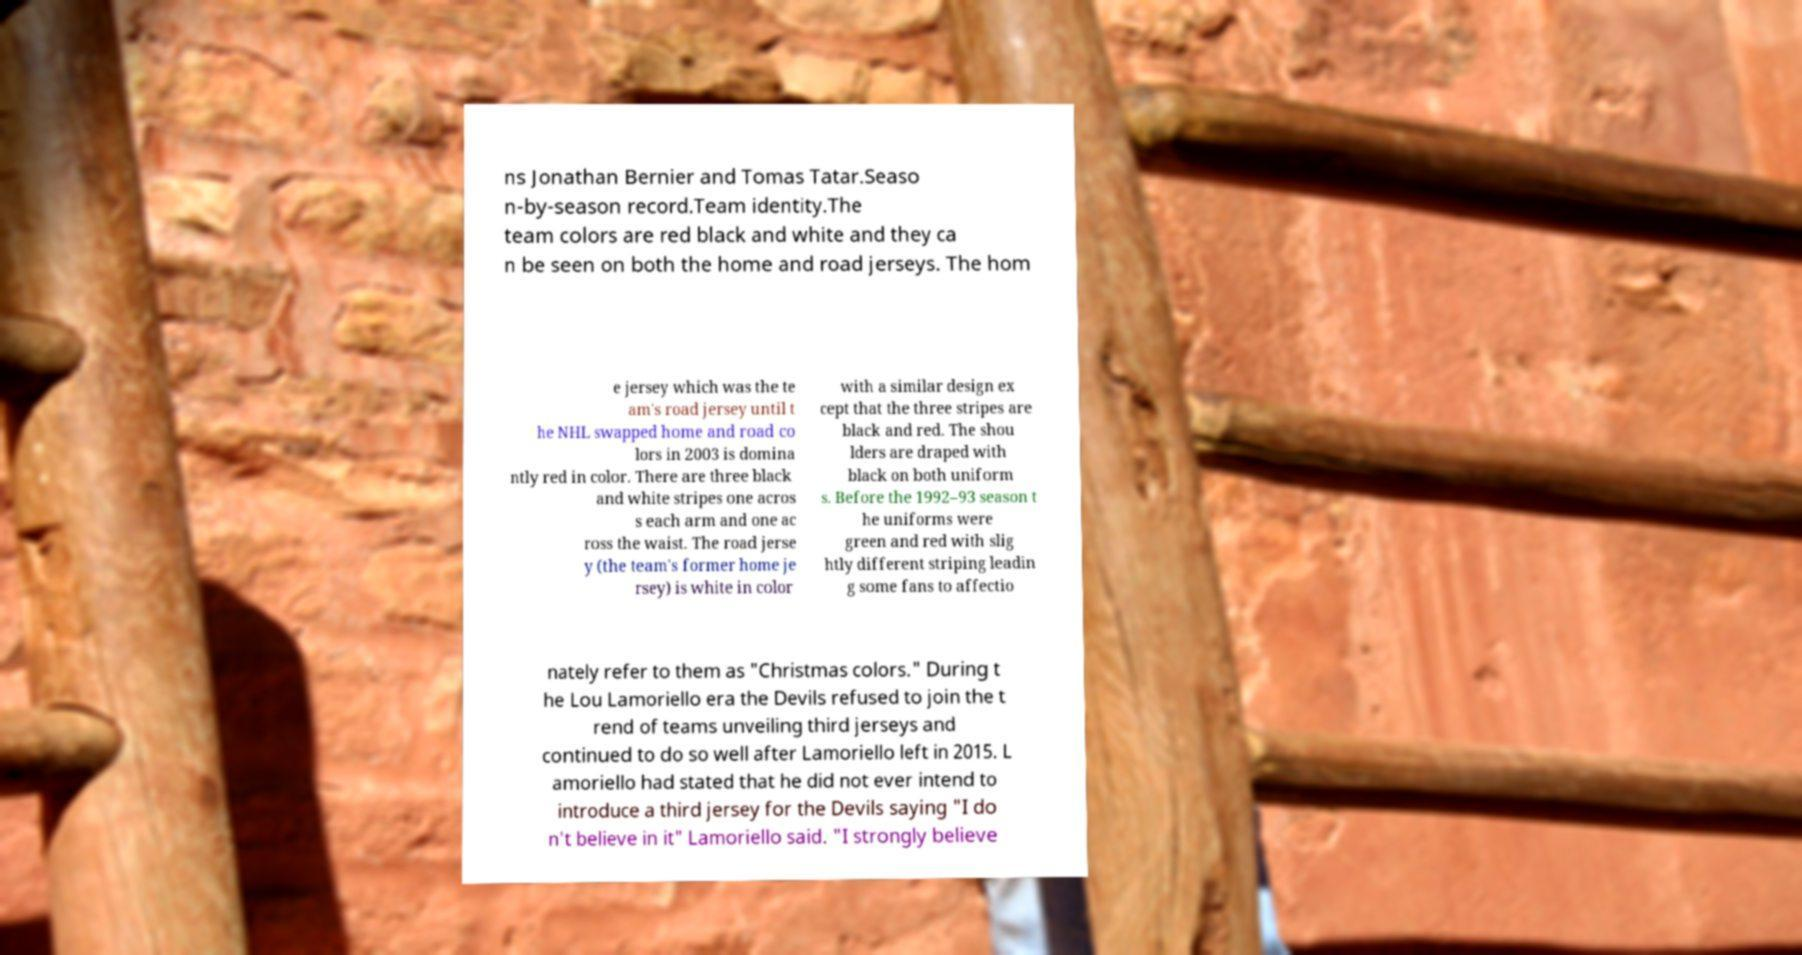Can you accurately transcribe the text from the provided image for me? ns Jonathan Bernier and Tomas Tatar.Seaso n-by-season record.Team identity.The team colors are red black and white and they ca n be seen on both the home and road jerseys. The hom e jersey which was the te am's road jersey until t he NHL swapped home and road co lors in 2003 is domina ntly red in color. There are three black and white stripes one acros s each arm and one ac ross the waist. The road jerse y (the team's former home je rsey) is white in color with a similar design ex cept that the three stripes are black and red. The shou lders are draped with black on both uniform s. Before the 1992–93 season t he uniforms were green and red with slig htly different striping leadin g some fans to affectio nately refer to them as "Christmas colors." During t he Lou Lamoriello era the Devils refused to join the t rend of teams unveiling third jerseys and continued to do so well after Lamoriello left in 2015. L amoriello had stated that he did not ever intend to introduce a third jersey for the Devils saying "I do n't believe in it" Lamoriello said. "I strongly believe 